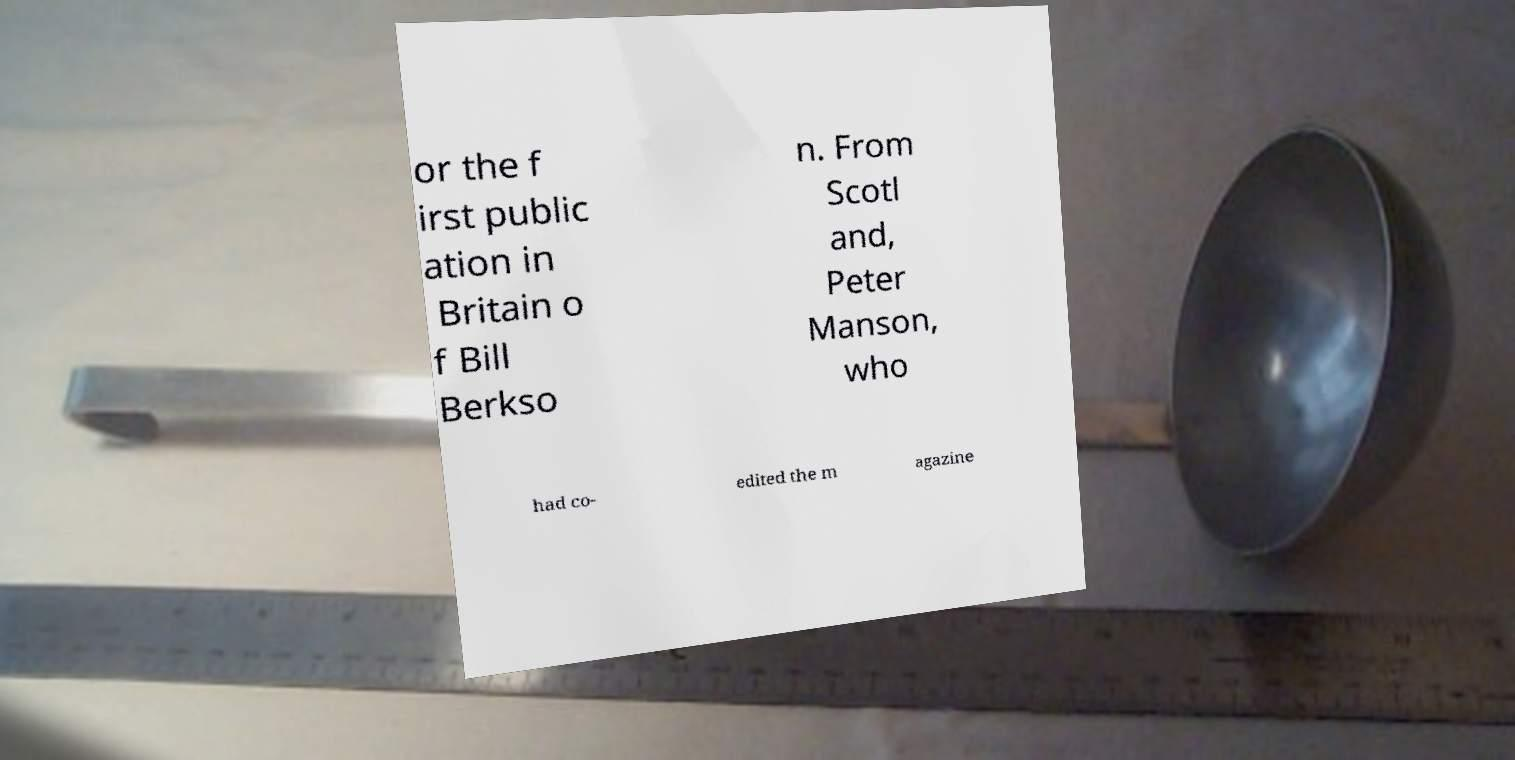For documentation purposes, I need the text within this image transcribed. Could you provide that? or the f irst public ation in Britain o f Bill Berkso n. From Scotl and, Peter Manson, who had co- edited the m agazine 